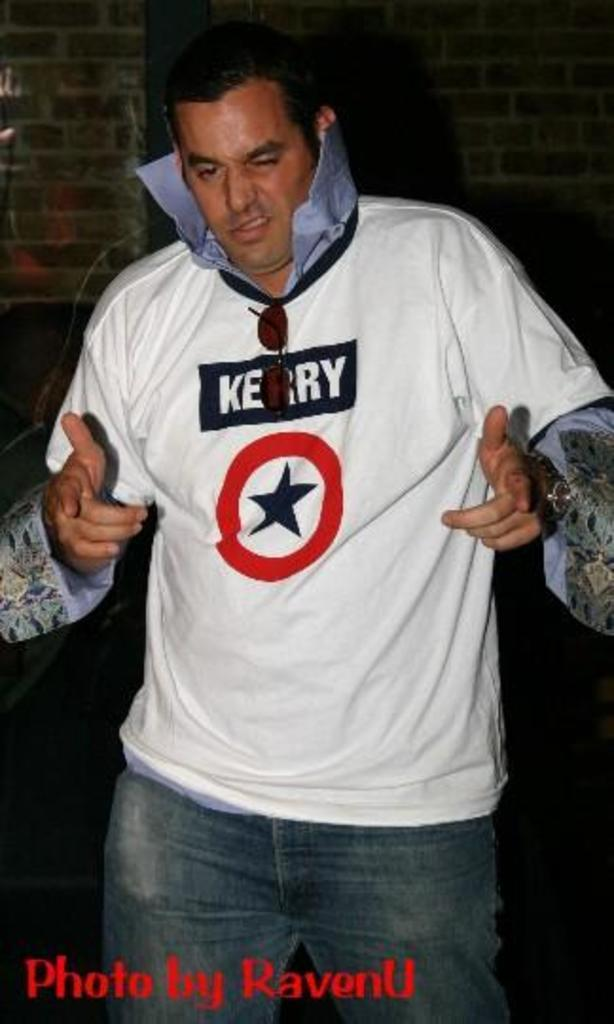<image>
Create a compact narrative representing the image presented. A man in a white shirt that says kerry makes two finger guns. 